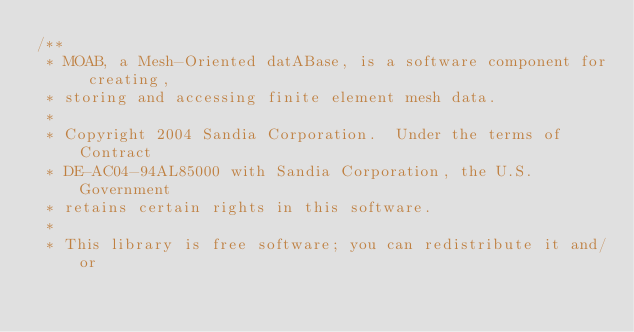Convert code to text. <code><loc_0><loc_0><loc_500><loc_500><_C++_>/**
 * MOAB, a Mesh-Oriented datABase, is a software component for creating,
 * storing and accessing finite element mesh data.
 * 
 * Copyright 2004 Sandia Corporation.  Under the terms of Contract
 * DE-AC04-94AL85000 with Sandia Corporation, the U.S. Government
 * retains certain rights in this software.
 * 
 * This library is free software; you can redistribute it and/or</code> 